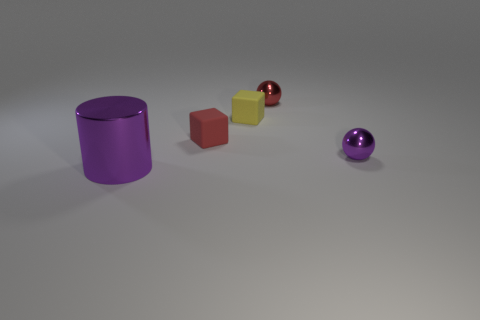Are the purple thing left of the purple sphere and the cube that is on the left side of the small yellow block made of the same material?
Keep it short and to the point. No. There is a purple shiny object left of the small yellow block; what is its size?
Offer a terse response. Large. The yellow cube has what size?
Your response must be concise. Small. What size is the metal ball to the left of the metal sphere that is right of the small metal sphere that is behind the yellow object?
Keep it short and to the point. Small. Are there any purple things that have the same material as the purple cylinder?
Your answer should be compact. Yes. There is a yellow thing; what shape is it?
Provide a short and direct response. Cube. There is a tiny cube that is the same material as the small yellow object; what color is it?
Provide a short and direct response. Red. How many blue objects are cylinders or spheres?
Provide a short and direct response. 0. Are there more big purple cylinders than tiny brown matte spheres?
Your answer should be compact. Yes. How many things are either metal objects to the right of the tiny red sphere or shiny balls that are on the left side of the purple ball?
Provide a succinct answer. 2. 